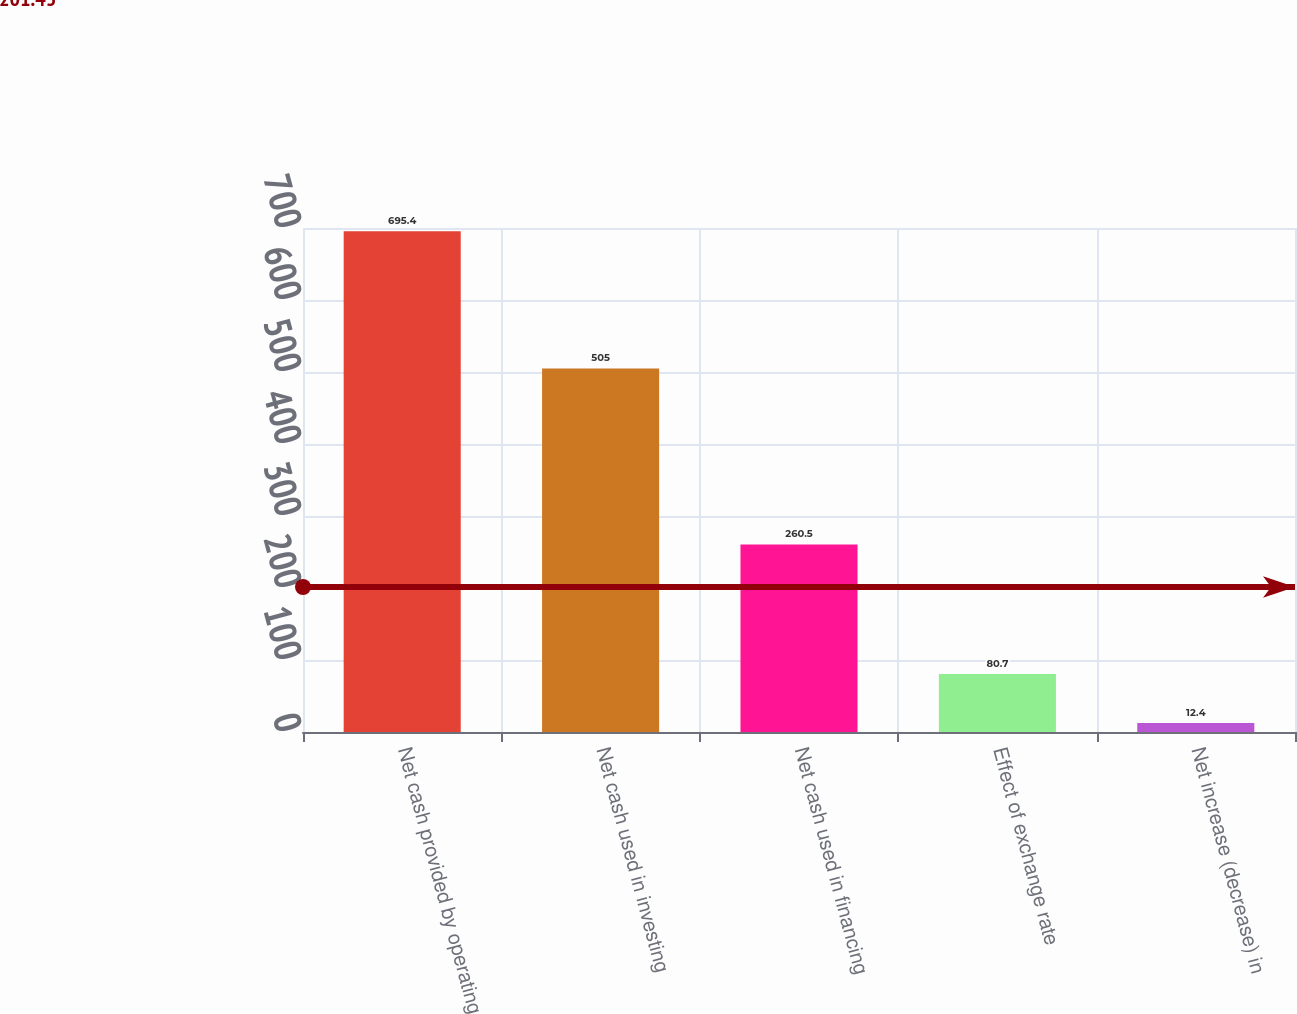<chart> <loc_0><loc_0><loc_500><loc_500><bar_chart><fcel>Net cash provided by operating<fcel>Net cash used in investing<fcel>Net cash used in financing<fcel>Effect of exchange rate<fcel>Net increase (decrease) in<nl><fcel>695.4<fcel>505<fcel>260.5<fcel>80.7<fcel>12.4<nl></chart> 